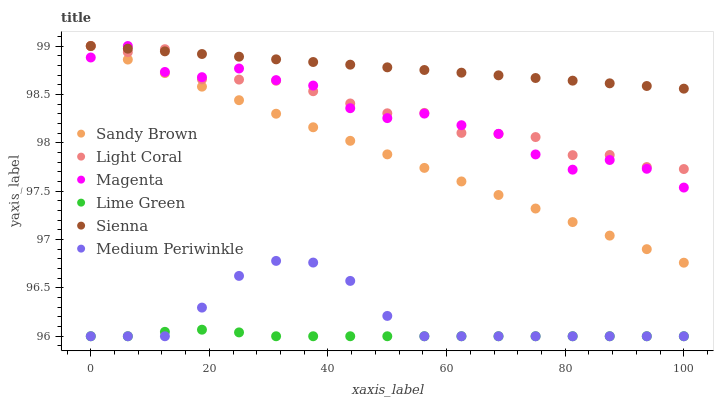Does Lime Green have the minimum area under the curve?
Answer yes or no. Yes. Does Sienna have the maximum area under the curve?
Answer yes or no. Yes. Does Sandy Brown have the minimum area under the curve?
Answer yes or no. No. Does Sandy Brown have the maximum area under the curve?
Answer yes or no. No. Is Sienna the smoothest?
Answer yes or no. Yes. Is Magenta the roughest?
Answer yes or no. Yes. Is Sandy Brown the smoothest?
Answer yes or no. No. Is Sandy Brown the roughest?
Answer yes or no. No. Does Medium Periwinkle have the lowest value?
Answer yes or no. Yes. Does Sandy Brown have the lowest value?
Answer yes or no. No. Does Magenta have the highest value?
Answer yes or no. Yes. Does Medium Periwinkle have the highest value?
Answer yes or no. No. Is Medium Periwinkle less than Magenta?
Answer yes or no. Yes. Is Light Coral greater than Lime Green?
Answer yes or no. Yes. Does Magenta intersect Light Coral?
Answer yes or no. Yes. Is Magenta less than Light Coral?
Answer yes or no. No. Is Magenta greater than Light Coral?
Answer yes or no. No. Does Medium Periwinkle intersect Magenta?
Answer yes or no. No. 